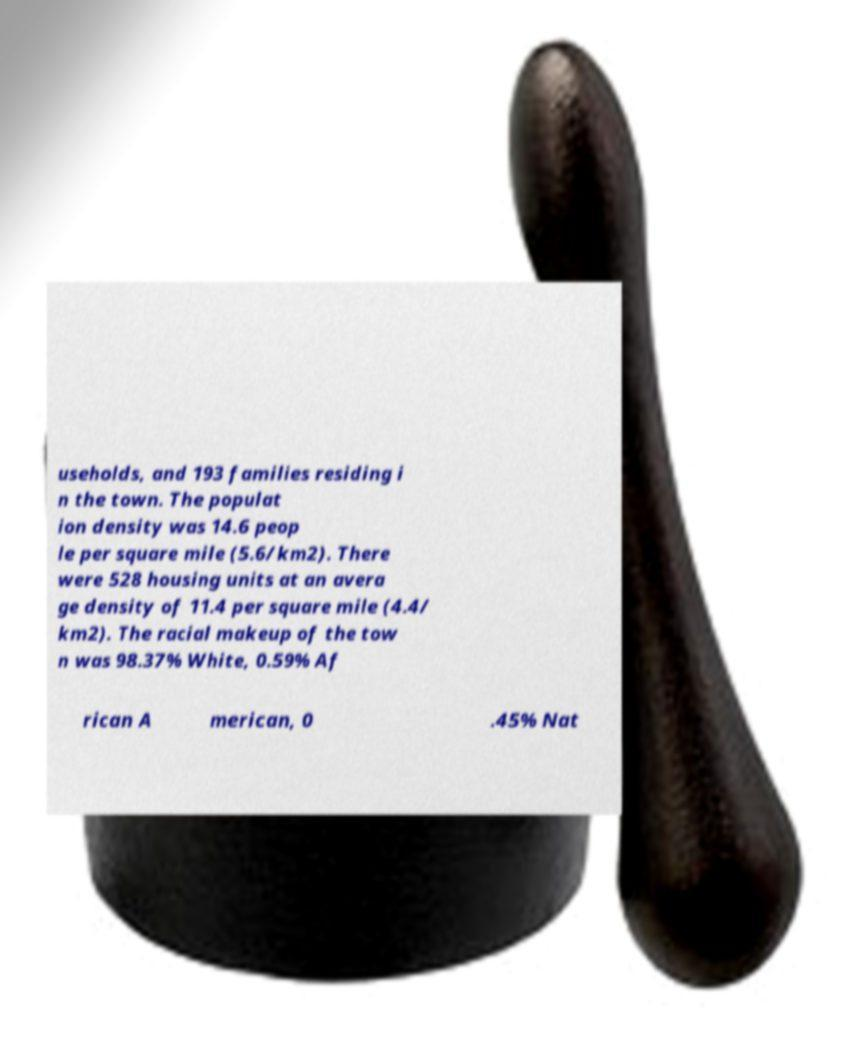Please identify and transcribe the text found in this image. useholds, and 193 families residing i n the town. The populat ion density was 14.6 peop le per square mile (5.6/km2). There were 528 housing units at an avera ge density of 11.4 per square mile (4.4/ km2). The racial makeup of the tow n was 98.37% White, 0.59% Af rican A merican, 0 .45% Nat 